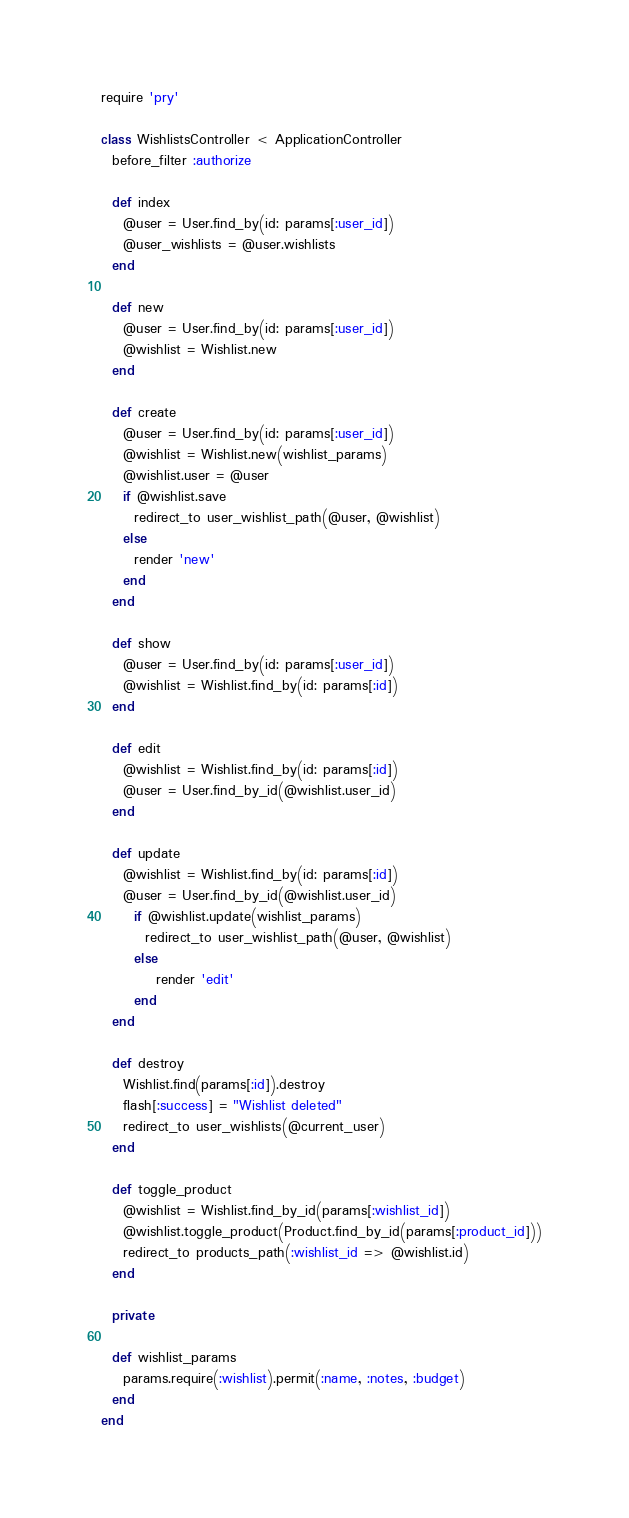<code> <loc_0><loc_0><loc_500><loc_500><_Ruby_>require 'pry'

class WishlistsController < ApplicationController
  before_filter :authorize
  
  def index
    @user = User.find_by(id: params[:user_id])
    @user_wishlists = @user.wishlists
  end

  def new
    @user = User.find_by(id: params[:user_id])
    @wishlist = Wishlist.new
  end

  def create
    @user = User.find_by(id: params[:user_id])
    @wishlist = Wishlist.new(wishlist_params)
    @wishlist.user = @user
    if @wishlist.save
      redirect_to user_wishlist_path(@user, @wishlist)
    else
      render 'new'
    end
  end

  def show
    @user = User.find_by(id: params[:user_id])
    @wishlist = Wishlist.find_by(id: params[:id])
  end

  def edit
    @wishlist = Wishlist.find_by(id: params[:id])
    @user = User.find_by_id(@wishlist.user_id)
  end

  def update
    @wishlist = Wishlist.find_by(id: params[:id])
    @user = User.find_by_id(@wishlist.user_id)
      if @wishlist.update(wishlist_params)
        redirect_to user_wishlist_path(@user, @wishlist)
      else
          render 'edit'
      end
  end

  def destroy
    Wishlist.find(params[:id]).destroy
    flash[:success] = "Wishlist deleted"
    redirect_to user_wishlists(@current_user)
  end

  def toggle_product
    @wishlist = Wishlist.find_by_id(params[:wishlist_id])
    @wishlist.toggle_product(Product.find_by_id(params[:product_id]))
    redirect_to products_path(:wishlist_id => @wishlist.id)
  end
  
  private

  def wishlist_params
    params.require(:wishlist).permit(:name, :notes, :budget)
  end
end
</code> 